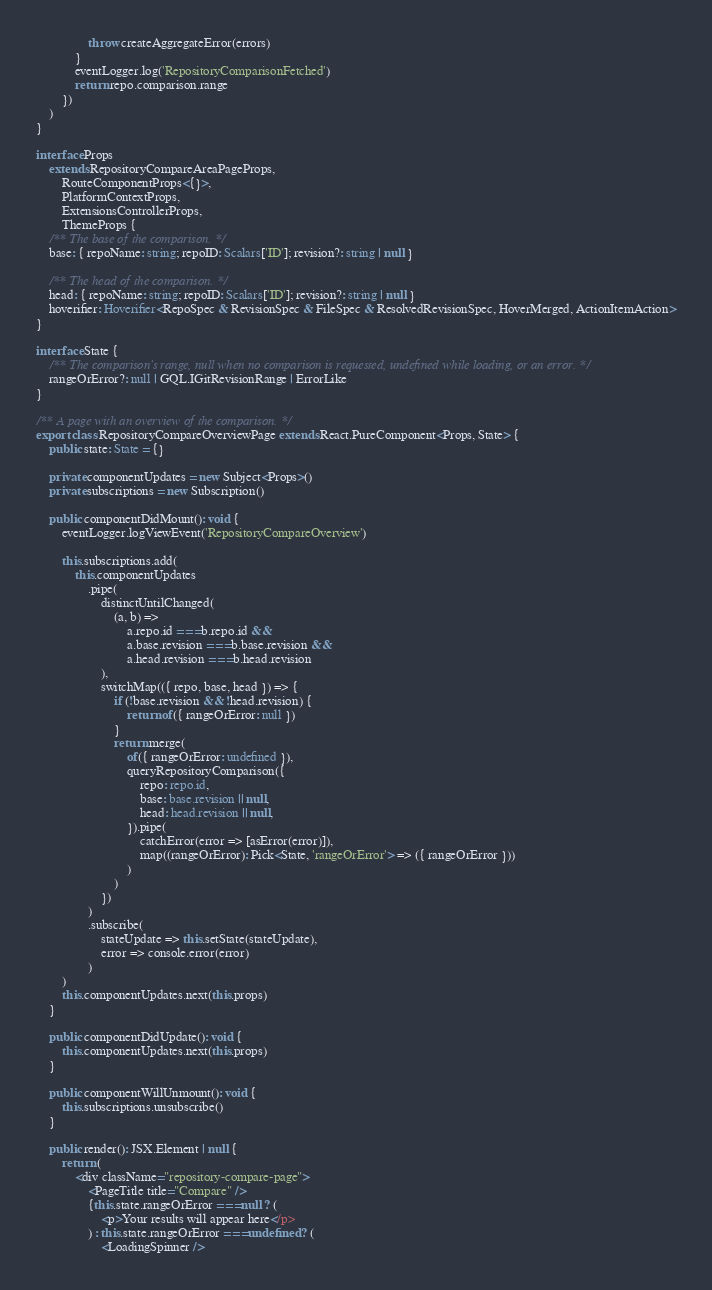Convert code to text. <code><loc_0><loc_0><loc_500><loc_500><_TypeScript_>                throw createAggregateError(errors)
            }
            eventLogger.log('RepositoryComparisonFetched')
            return repo.comparison.range
        })
    )
}

interface Props
    extends RepositoryCompareAreaPageProps,
        RouteComponentProps<{}>,
        PlatformContextProps,
        ExtensionsControllerProps,
        ThemeProps {
    /** The base of the comparison. */
    base: { repoName: string; repoID: Scalars['ID']; revision?: string | null }

    /** The head of the comparison. */
    head: { repoName: string; repoID: Scalars['ID']; revision?: string | null }
    hoverifier: Hoverifier<RepoSpec & RevisionSpec & FileSpec & ResolvedRevisionSpec, HoverMerged, ActionItemAction>
}

interface State {
    /** The comparison's range, null when no comparison is requested, undefined while loading, or an error. */
    rangeOrError?: null | GQL.IGitRevisionRange | ErrorLike
}

/** A page with an overview of the comparison. */
export class RepositoryCompareOverviewPage extends React.PureComponent<Props, State> {
    public state: State = {}

    private componentUpdates = new Subject<Props>()
    private subscriptions = new Subscription()

    public componentDidMount(): void {
        eventLogger.logViewEvent('RepositoryCompareOverview')

        this.subscriptions.add(
            this.componentUpdates
                .pipe(
                    distinctUntilChanged(
                        (a, b) =>
                            a.repo.id === b.repo.id &&
                            a.base.revision === b.base.revision &&
                            a.head.revision === b.head.revision
                    ),
                    switchMap(({ repo, base, head }) => {
                        if (!base.revision && !head.revision) {
                            return of({ rangeOrError: null })
                        }
                        return merge(
                            of({ rangeOrError: undefined }),
                            queryRepositoryComparison({
                                repo: repo.id,
                                base: base.revision || null,
                                head: head.revision || null,
                            }).pipe(
                                catchError(error => [asError(error)]),
                                map((rangeOrError): Pick<State, 'rangeOrError'> => ({ rangeOrError }))
                            )
                        )
                    })
                )
                .subscribe(
                    stateUpdate => this.setState(stateUpdate),
                    error => console.error(error)
                )
        )
        this.componentUpdates.next(this.props)
    }

    public componentDidUpdate(): void {
        this.componentUpdates.next(this.props)
    }

    public componentWillUnmount(): void {
        this.subscriptions.unsubscribe()
    }

    public render(): JSX.Element | null {
        return (
            <div className="repository-compare-page">
                <PageTitle title="Compare" />
                {this.state.rangeOrError === null ? (
                    <p>Your results will appear here</p>
                ) : this.state.rangeOrError === undefined ? (
                    <LoadingSpinner /></code> 